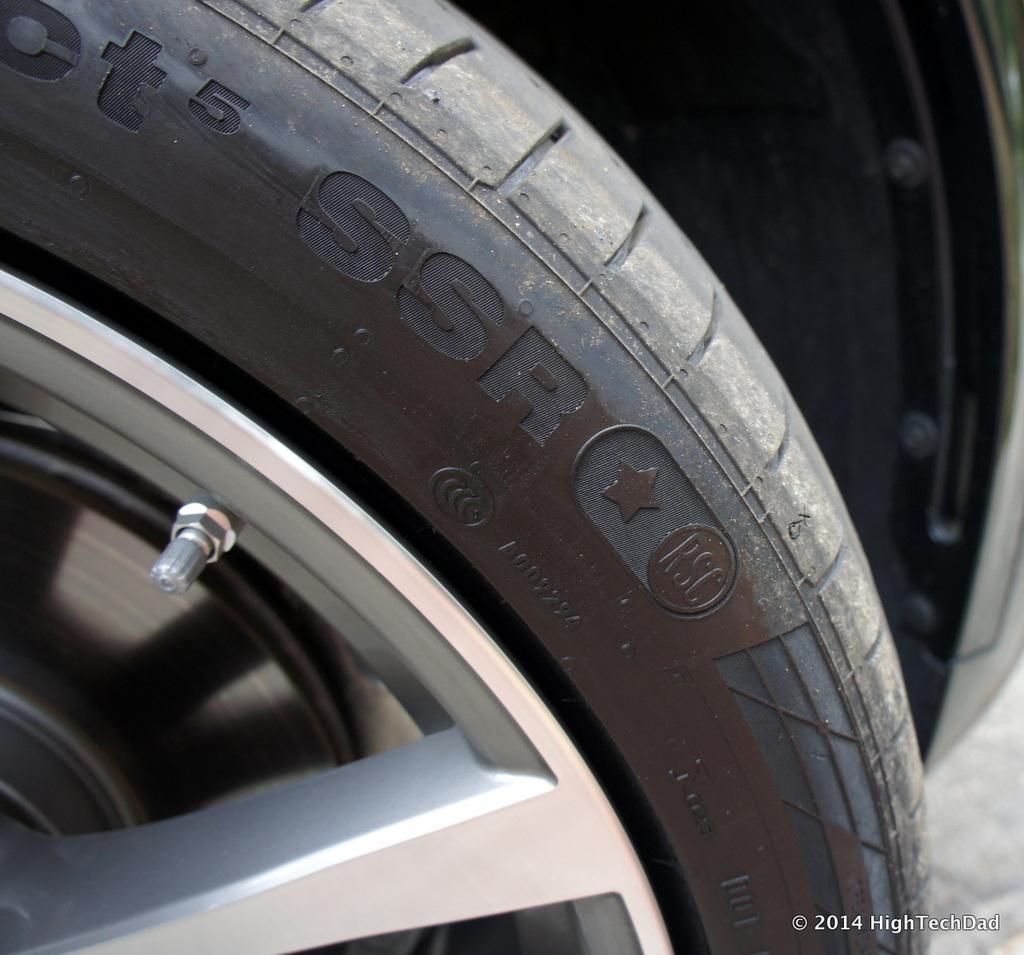What object is the main focus of the image? There is a tyre in the image. What type of vehicle might the tyre belong to? The tyre is likely from a vehicle. Can you describe any specific features on the tyre? There is a screw on the left side of the tyre and a disk brake on the left side of the tyre. Is there any indication of the image's origin or ownership? Yes, there is a watermark in the image. What type of cheese is being used as bait in the image? There is no cheese or bait present in the image; it features a tyre with a screw and disk brake. How is the kite attached to the tyre in the image? There is no kite present in the image; it only shows a tyre with a screw and disk brake. 